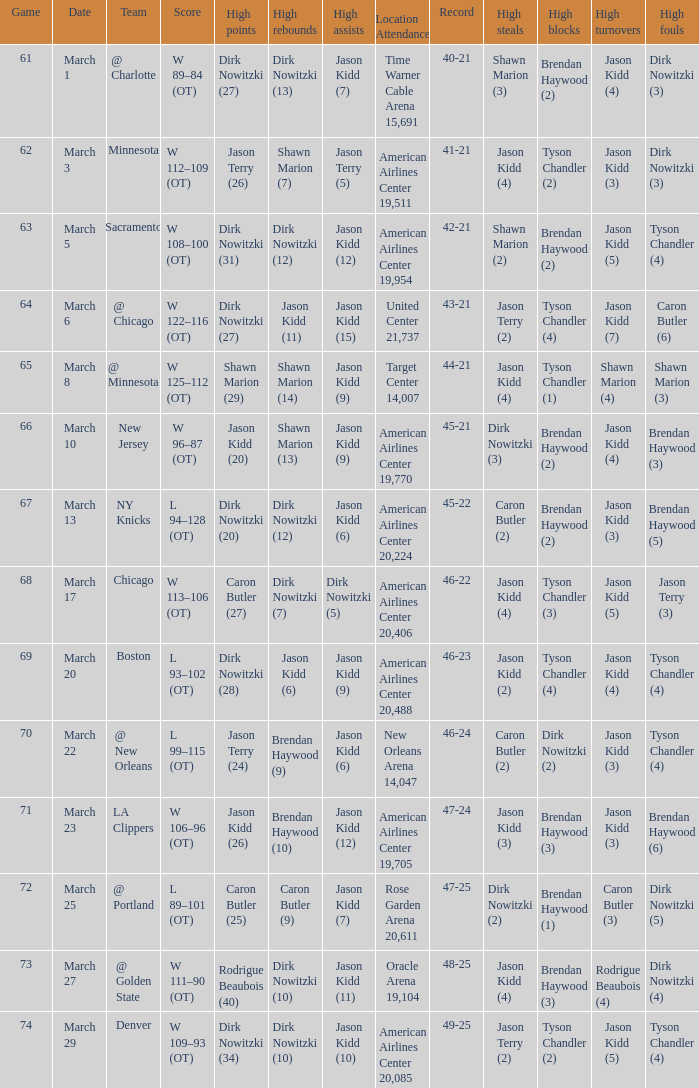How many games had been played when the Mavericks had a 46-22 record? 68.0. 